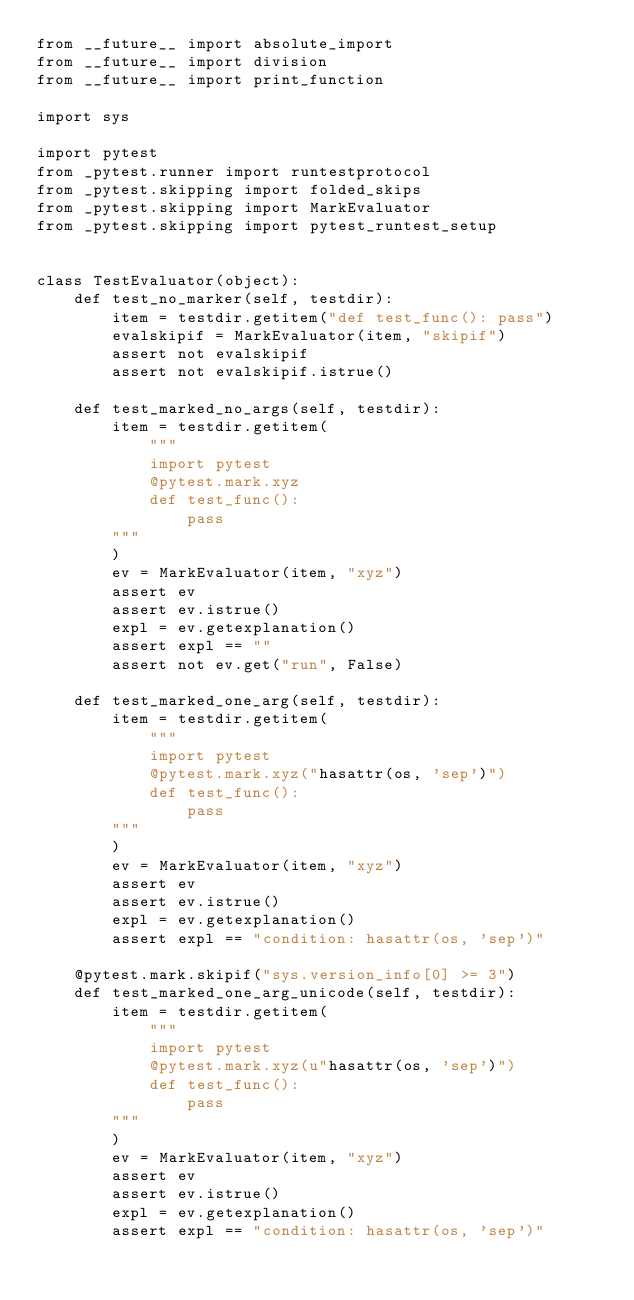<code> <loc_0><loc_0><loc_500><loc_500><_Python_>from __future__ import absolute_import
from __future__ import division
from __future__ import print_function

import sys

import pytest
from _pytest.runner import runtestprotocol
from _pytest.skipping import folded_skips
from _pytest.skipping import MarkEvaluator
from _pytest.skipping import pytest_runtest_setup


class TestEvaluator(object):
    def test_no_marker(self, testdir):
        item = testdir.getitem("def test_func(): pass")
        evalskipif = MarkEvaluator(item, "skipif")
        assert not evalskipif
        assert not evalskipif.istrue()

    def test_marked_no_args(self, testdir):
        item = testdir.getitem(
            """
            import pytest
            @pytest.mark.xyz
            def test_func():
                pass
        """
        )
        ev = MarkEvaluator(item, "xyz")
        assert ev
        assert ev.istrue()
        expl = ev.getexplanation()
        assert expl == ""
        assert not ev.get("run", False)

    def test_marked_one_arg(self, testdir):
        item = testdir.getitem(
            """
            import pytest
            @pytest.mark.xyz("hasattr(os, 'sep')")
            def test_func():
                pass
        """
        )
        ev = MarkEvaluator(item, "xyz")
        assert ev
        assert ev.istrue()
        expl = ev.getexplanation()
        assert expl == "condition: hasattr(os, 'sep')"

    @pytest.mark.skipif("sys.version_info[0] >= 3")
    def test_marked_one_arg_unicode(self, testdir):
        item = testdir.getitem(
            """
            import pytest
            @pytest.mark.xyz(u"hasattr(os, 'sep')")
            def test_func():
                pass
        """
        )
        ev = MarkEvaluator(item, "xyz")
        assert ev
        assert ev.istrue()
        expl = ev.getexplanation()
        assert expl == "condition: hasattr(os, 'sep')"
</code> 